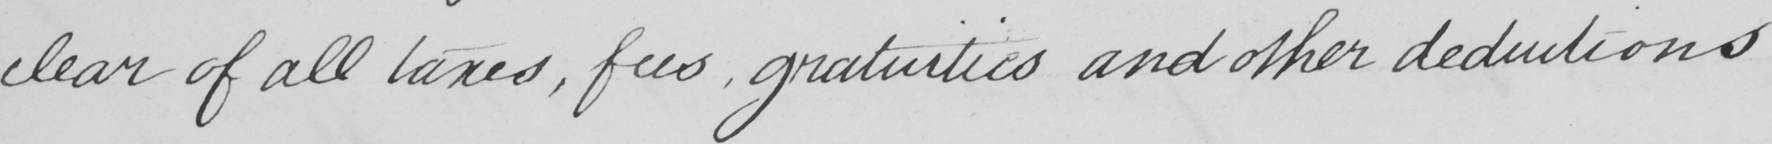What is written in this line of handwriting? clear of all taxes , fees , gratuities and other deductions 